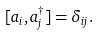Convert formula to latex. <formula><loc_0><loc_0><loc_500><loc_500>[ a _ { i } , a _ { j } ^ { \dagger } ] = \delta _ { i j } .</formula> 